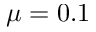Convert formula to latex. <formula><loc_0><loc_0><loc_500><loc_500>\mu = 0 . 1</formula> 